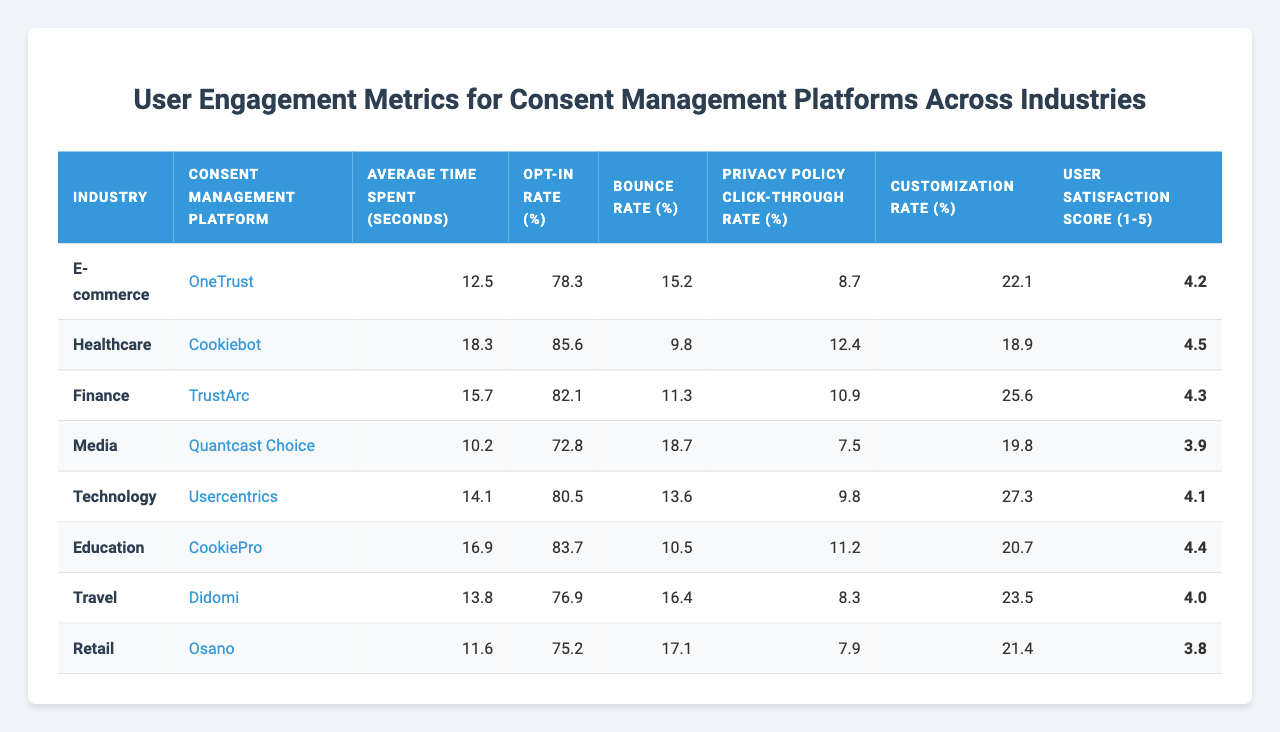What is the highest opt-in rate among the industries listed? By examining the "Opt-in Rate (%)" column in the table, we see the healthcare industry with an opt-in rate of 85.6%, which is the highest value compared to other industries.
Answer: 85.6% Which consent management platform has the lowest average time spent? The "Average Time Spent (seconds)" column shows that the media industry, using the Quantcast Choice platform, has the lowest time spent at 10.2 seconds.
Answer: 10.2 seconds Is the customization rate higher in the finance industry compared to the e-commerce industry? In the "Customization Rate (%)" column, finance is at 25.6%, whereas e-commerce is at 22.1%. Since 25.6% is greater than 22.1%, the finance industry's customization rate is higher.
Answer: Yes What is the average user satisfaction score across all industries? To find the average, add all user satisfaction scores: (4.2 + 4.5 + 4.3 + 3.9 + 4.1 + 4.4 + 4.0 + 3.8) = 33.2. Since there are 8 industries, the average is 33.2 / 8 = 4.15.
Answer: 4.15 Which industry has the highest privacy policy click-through rate? Looking at the "Privacy Policy Click-through Rate (%)" column, healthcare has the highest rate at 12.4%, compared to other values listed.
Answer: 12.4% How does the bounce rate for the technology industry compare to that of retail? For technology, the bounce rate is 13.6%, while for retail, it is 17.1%. Comparing these, technology has a lower bounce rate than retail, making the technology industry's engagement stronger.
Answer: Technology has a lower bounce rate If we combine the opt-in rates of e-commerce and retail, what is the total? The opt-in rates are 78.3% for e-commerce and 75.2% for retail. Adding them gives 78.3 + 75.2 = 153.5%, so the total opt-in rate for these two industries is 153.5%.
Answer: 153.5% Which industry has the highest average time spent and what is that time? By checking the "Average Time Spent (seconds)" column, the healthcare industry has the highest average time spent at 18.3 seconds.
Answer: 18.3 seconds Is the average time spent longer in the education industry than in the travel industry? The education industry averages 16.9 seconds, whereas the travel industry averages 13.8 seconds. Since 16.9 seconds is greater than 13.8 seconds, education does indeed have a longer average time spent.
Answer: Yes What can be inferred about user satisfaction and opt-in rates in the e-commerce industry? The e-commerce industry has a user satisfaction score of 4.2 and an opt-in rate of 78.3%. These indicate a moderately high satisfaction level, suggesting that users are generally pleased with their consent experience, though not the highest in the list.
Answer: Users are moderately satisfied 